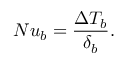Convert formula to latex. <formula><loc_0><loc_0><loc_500><loc_500>N u _ { b } = \frac { \Delta T _ { b } } { \delta _ { b } } .</formula> 